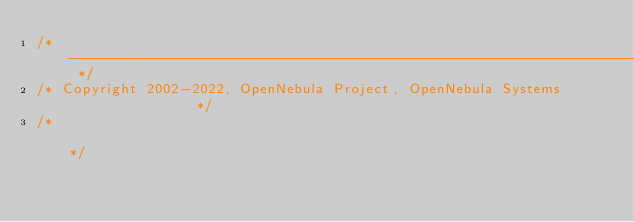Convert code to text. <code><loc_0><loc_0><loc_500><loc_500><_C++_>/* -------------------------------------------------------------------------- */
/* Copyright 2002-2022, OpenNebula Project, OpenNebula Systems                */
/*                                                                            */</code> 